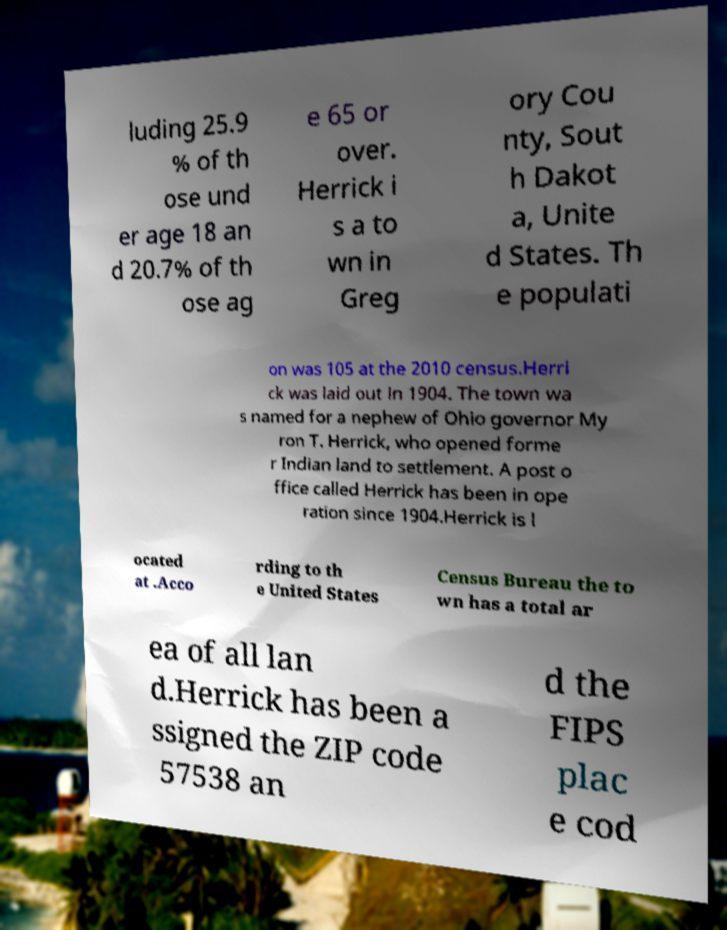What messages or text are displayed in this image? I need them in a readable, typed format. luding 25.9 % of th ose und er age 18 an d 20.7% of th ose ag e 65 or over. Herrick i s a to wn in Greg ory Cou nty, Sout h Dakot a, Unite d States. Th e populati on was 105 at the 2010 census.Herri ck was laid out in 1904. The town wa s named for a nephew of Ohio governor My ron T. Herrick, who opened forme r Indian land to settlement. A post o ffice called Herrick has been in ope ration since 1904.Herrick is l ocated at .Acco rding to th e United States Census Bureau the to wn has a total ar ea of all lan d.Herrick has been a ssigned the ZIP code 57538 an d the FIPS plac e cod 